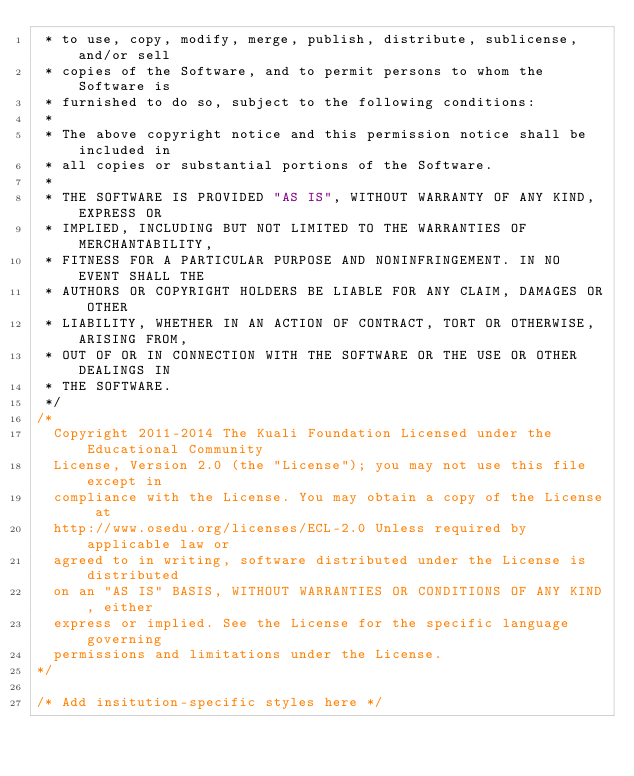Convert code to text. <code><loc_0><loc_0><loc_500><loc_500><_CSS_> * to use, copy, modify, merge, publish, distribute, sublicense, and/or sell
 * copies of the Software, and to permit persons to whom the Software is
 * furnished to do so, subject to the following conditions:
 *
 * The above copyright notice and this permission notice shall be included in
 * all copies or substantial portions of the Software.
 *
 * THE SOFTWARE IS PROVIDED "AS IS", WITHOUT WARRANTY OF ANY KIND, EXPRESS OR
 * IMPLIED, INCLUDING BUT NOT LIMITED TO THE WARRANTIES OF MERCHANTABILITY,
 * FITNESS FOR A PARTICULAR PURPOSE AND NONINFRINGEMENT. IN NO EVENT SHALL THE
 * AUTHORS OR COPYRIGHT HOLDERS BE LIABLE FOR ANY CLAIM, DAMAGES OR OTHER
 * LIABILITY, WHETHER IN AN ACTION OF CONTRACT, TORT OR OTHERWISE, ARISING FROM,
 * OUT OF OR IN CONNECTION WITH THE SOFTWARE OR THE USE OR OTHER DEALINGS IN
 * THE SOFTWARE.
 */
/*
  Copyright 2011-2014 The Kuali Foundation Licensed under the Educational Community
  License, Version 2.0 (the "License"); you may not use this file except in
  compliance with the License. You may obtain a copy of the License at
  http://www.osedu.org/licenses/ECL-2.0 Unless required by applicable law or
  agreed to in writing, software distributed under the License is distributed
  on an "AS IS" BASIS, WITHOUT WARRANTIES OR CONDITIONS OF ANY KIND, either
  express or implied. See the License for the specific language governing
  permissions and limitations under the License.
*/

/* Add insitution-specific styles here */</code> 